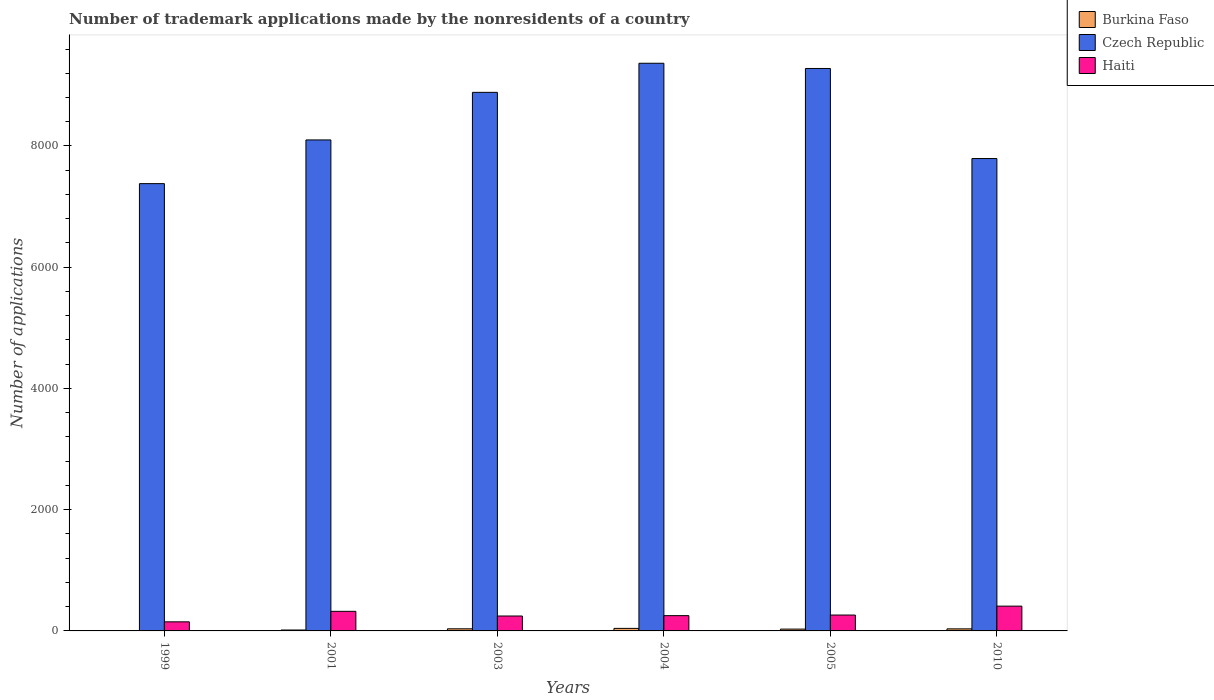How many groups of bars are there?
Make the answer very short. 6. Are the number of bars per tick equal to the number of legend labels?
Offer a very short reply. Yes. Are the number of bars on each tick of the X-axis equal?
Your response must be concise. Yes. How many bars are there on the 4th tick from the left?
Provide a short and direct response. 3. What is the label of the 5th group of bars from the left?
Provide a succinct answer. 2005. What is the number of trademark applications made by the nonresidents in Czech Republic in 2003?
Ensure brevity in your answer.  8885. Across all years, what is the maximum number of trademark applications made by the nonresidents in Czech Republic?
Make the answer very short. 9365. Across all years, what is the minimum number of trademark applications made by the nonresidents in Haiti?
Keep it short and to the point. 150. What is the total number of trademark applications made by the nonresidents in Burkina Faso in the graph?
Your answer should be very brief. 157. What is the difference between the number of trademark applications made by the nonresidents in Haiti in 2004 and that in 2010?
Provide a short and direct response. -157. What is the difference between the number of trademark applications made by the nonresidents in Haiti in 2003 and the number of trademark applications made by the nonresidents in Burkina Faso in 1999?
Offer a very short reply. 245. What is the average number of trademark applications made by the nonresidents in Burkina Faso per year?
Provide a short and direct response. 26.17. In the year 1999, what is the difference between the number of trademark applications made by the nonresidents in Haiti and number of trademark applications made by the nonresidents in Burkina Faso?
Your response must be concise. 149. What is the ratio of the number of trademark applications made by the nonresidents in Haiti in 1999 to that in 2001?
Provide a succinct answer. 0.46. Is the number of trademark applications made by the nonresidents in Haiti in 2001 less than that in 2005?
Provide a short and direct response. No. What is the difference between the highest and the lowest number of trademark applications made by the nonresidents in Czech Republic?
Offer a very short reply. 1986. In how many years, is the number of trademark applications made by the nonresidents in Burkina Faso greater than the average number of trademark applications made by the nonresidents in Burkina Faso taken over all years?
Keep it short and to the point. 4. Is the sum of the number of trademark applications made by the nonresidents in Haiti in 2005 and 2010 greater than the maximum number of trademark applications made by the nonresidents in Burkina Faso across all years?
Make the answer very short. Yes. What does the 3rd bar from the left in 2005 represents?
Offer a terse response. Haiti. What does the 1st bar from the right in 2001 represents?
Provide a short and direct response. Haiti. Is it the case that in every year, the sum of the number of trademark applications made by the nonresidents in Burkina Faso and number of trademark applications made by the nonresidents in Haiti is greater than the number of trademark applications made by the nonresidents in Czech Republic?
Offer a very short reply. No. What is the difference between two consecutive major ticks on the Y-axis?
Give a very brief answer. 2000. Does the graph contain any zero values?
Offer a terse response. No. What is the title of the graph?
Give a very brief answer. Number of trademark applications made by the nonresidents of a country. Does "Egypt, Arab Rep." appear as one of the legend labels in the graph?
Offer a very short reply. No. What is the label or title of the Y-axis?
Give a very brief answer. Number of applications. What is the Number of applications of Czech Republic in 1999?
Keep it short and to the point. 7379. What is the Number of applications in Haiti in 1999?
Offer a very short reply. 150. What is the Number of applications in Burkina Faso in 2001?
Your answer should be compact. 15. What is the Number of applications of Czech Republic in 2001?
Your response must be concise. 8100. What is the Number of applications of Haiti in 2001?
Make the answer very short. 323. What is the Number of applications in Czech Republic in 2003?
Give a very brief answer. 8885. What is the Number of applications in Haiti in 2003?
Ensure brevity in your answer.  246. What is the Number of applications in Czech Republic in 2004?
Provide a succinct answer. 9365. What is the Number of applications in Haiti in 2004?
Make the answer very short. 252. What is the Number of applications in Czech Republic in 2005?
Offer a terse response. 9279. What is the Number of applications of Haiti in 2005?
Offer a very short reply. 262. What is the Number of applications in Burkina Faso in 2010?
Your answer should be very brief. 34. What is the Number of applications in Czech Republic in 2010?
Provide a short and direct response. 7793. What is the Number of applications in Haiti in 2010?
Offer a very short reply. 409. Across all years, what is the maximum Number of applications in Czech Republic?
Offer a terse response. 9365. Across all years, what is the maximum Number of applications in Haiti?
Offer a very short reply. 409. Across all years, what is the minimum Number of applications of Czech Republic?
Make the answer very short. 7379. Across all years, what is the minimum Number of applications of Haiti?
Your answer should be very brief. 150. What is the total Number of applications of Burkina Faso in the graph?
Your response must be concise. 157. What is the total Number of applications in Czech Republic in the graph?
Ensure brevity in your answer.  5.08e+04. What is the total Number of applications of Haiti in the graph?
Keep it short and to the point. 1642. What is the difference between the Number of applications of Burkina Faso in 1999 and that in 2001?
Provide a succinct answer. -14. What is the difference between the Number of applications of Czech Republic in 1999 and that in 2001?
Your answer should be very brief. -721. What is the difference between the Number of applications of Haiti in 1999 and that in 2001?
Offer a terse response. -173. What is the difference between the Number of applications of Burkina Faso in 1999 and that in 2003?
Keep it short and to the point. -34. What is the difference between the Number of applications in Czech Republic in 1999 and that in 2003?
Offer a very short reply. -1506. What is the difference between the Number of applications in Haiti in 1999 and that in 2003?
Give a very brief answer. -96. What is the difference between the Number of applications in Burkina Faso in 1999 and that in 2004?
Make the answer very short. -41. What is the difference between the Number of applications in Czech Republic in 1999 and that in 2004?
Provide a succinct answer. -1986. What is the difference between the Number of applications in Haiti in 1999 and that in 2004?
Make the answer very short. -102. What is the difference between the Number of applications in Czech Republic in 1999 and that in 2005?
Provide a succinct answer. -1900. What is the difference between the Number of applications of Haiti in 1999 and that in 2005?
Offer a terse response. -112. What is the difference between the Number of applications in Burkina Faso in 1999 and that in 2010?
Ensure brevity in your answer.  -33. What is the difference between the Number of applications in Czech Republic in 1999 and that in 2010?
Your answer should be compact. -414. What is the difference between the Number of applications in Haiti in 1999 and that in 2010?
Keep it short and to the point. -259. What is the difference between the Number of applications in Czech Republic in 2001 and that in 2003?
Keep it short and to the point. -785. What is the difference between the Number of applications in Czech Republic in 2001 and that in 2004?
Give a very brief answer. -1265. What is the difference between the Number of applications of Czech Republic in 2001 and that in 2005?
Your answer should be compact. -1179. What is the difference between the Number of applications of Czech Republic in 2001 and that in 2010?
Give a very brief answer. 307. What is the difference between the Number of applications in Haiti in 2001 and that in 2010?
Ensure brevity in your answer.  -86. What is the difference between the Number of applications in Burkina Faso in 2003 and that in 2004?
Offer a terse response. -7. What is the difference between the Number of applications in Czech Republic in 2003 and that in 2004?
Make the answer very short. -480. What is the difference between the Number of applications in Burkina Faso in 2003 and that in 2005?
Keep it short and to the point. 5. What is the difference between the Number of applications of Czech Republic in 2003 and that in 2005?
Make the answer very short. -394. What is the difference between the Number of applications in Czech Republic in 2003 and that in 2010?
Ensure brevity in your answer.  1092. What is the difference between the Number of applications in Haiti in 2003 and that in 2010?
Offer a terse response. -163. What is the difference between the Number of applications of Burkina Faso in 2004 and that in 2010?
Give a very brief answer. 8. What is the difference between the Number of applications in Czech Republic in 2004 and that in 2010?
Your answer should be very brief. 1572. What is the difference between the Number of applications in Haiti in 2004 and that in 2010?
Make the answer very short. -157. What is the difference between the Number of applications of Czech Republic in 2005 and that in 2010?
Make the answer very short. 1486. What is the difference between the Number of applications of Haiti in 2005 and that in 2010?
Provide a short and direct response. -147. What is the difference between the Number of applications in Burkina Faso in 1999 and the Number of applications in Czech Republic in 2001?
Your answer should be compact. -8099. What is the difference between the Number of applications in Burkina Faso in 1999 and the Number of applications in Haiti in 2001?
Provide a short and direct response. -322. What is the difference between the Number of applications in Czech Republic in 1999 and the Number of applications in Haiti in 2001?
Offer a very short reply. 7056. What is the difference between the Number of applications of Burkina Faso in 1999 and the Number of applications of Czech Republic in 2003?
Your answer should be compact. -8884. What is the difference between the Number of applications of Burkina Faso in 1999 and the Number of applications of Haiti in 2003?
Keep it short and to the point. -245. What is the difference between the Number of applications of Czech Republic in 1999 and the Number of applications of Haiti in 2003?
Your response must be concise. 7133. What is the difference between the Number of applications in Burkina Faso in 1999 and the Number of applications in Czech Republic in 2004?
Offer a very short reply. -9364. What is the difference between the Number of applications of Burkina Faso in 1999 and the Number of applications of Haiti in 2004?
Your response must be concise. -251. What is the difference between the Number of applications in Czech Republic in 1999 and the Number of applications in Haiti in 2004?
Your response must be concise. 7127. What is the difference between the Number of applications in Burkina Faso in 1999 and the Number of applications in Czech Republic in 2005?
Offer a very short reply. -9278. What is the difference between the Number of applications of Burkina Faso in 1999 and the Number of applications of Haiti in 2005?
Keep it short and to the point. -261. What is the difference between the Number of applications in Czech Republic in 1999 and the Number of applications in Haiti in 2005?
Make the answer very short. 7117. What is the difference between the Number of applications of Burkina Faso in 1999 and the Number of applications of Czech Republic in 2010?
Your response must be concise. -7792. What is the difference between the Number of applications in Burkina Faso in 1999 and the Number of applications in Haiti in 2010?
Ensure brevity in your answer.  -408. What is the difference between the Number of applications of Czech Republic in 1999 and the Number of applications of Haiti in 2010?
Your response must be concise. 6970. What is the difference between the Number of applications of Burkina Faso in 2001 and the Number of applications of Czech Republic in 2003?
Make the answer very short. -8870. What is the difference between the Number of applications in Burkina Faso in 2001 and the Number of applications in Haiti in 2003?
Your answer should be compact. -231. What is the difference between the Number of applications of Czech Republic in 2001 and the Number of applications of Haiti in 2003?
Provide a short and direct response. 7854. What is the difference between the Number of applications of Burkina Faso in 2001 and the Number of applications of Czech Republic in 2004?
Keep it short and to the point. -9350. What is the difference between the Number of applications in Burkina Faso in 2001 and the Number of applications in Haiti in 2004?
Your answer should be compact. -237. What is the difference between the Number of applications in Czech Republic in 2001 and the Number of applications in Haiti in 2004?
Keep it short and to the point. 7848. What is the difference between the Number of applications of Burkina Faso in 2001 and the Number of applications of Czech Republic in 2005?
Keep it short and to the point. -9264. What is the difference between the Number of applications of Burkina Faso in 2001 and the Number of applications of Haiti in 2005?
Ensure brevity in your answer.  -247. What is the difference between the Number of applications of Czech Republic in 2001 and the Number of applications of Haiti in 2005?
Ensure brevity in your answer.  7838. What is the difference between the Number of applications in Burkina Faso in 2001 and the Number of applications in Czech Republic in 2010?
Your answer should be very brief. -7778. What is the difference between the Number of applications in Burkina Faso in 2001 and the Number of applications in Haiti in 2010?
Provide a succinct answer. -394. What is the difference between the Number of applications in Czech Republic in 2001 and the Number of applications in Haiti in 2010?
Provide a short and direct response. 7691. What is the difference between the Number of applications of Burkina Faso in 2003 and the Number of applications of Czech Republic in 2004?
Your answer should be compact. -9330. What is the difference between the Number of applications in Burkina Faso in 2003 and the Number of applications in Haiti in 2004?
Provide a short and direct response. -217. What is the difference between the Number of applications of Czech Republic in 2003 and the Number of applications of Haiti in 2004?
Offer a terse response. 8633. What is the difference between the Number of applications in Burkina Faso in 2003 and the Number of applications in Czech Republic in 2005?
Give a very brief answer. -9244. What is the difference between the Number of applications of Burkina Faso in 2003 and the Number of applications of Haiti in 2005?
Your answer should be very brief. -227. What is the difference between the Number of applications of Czech Republic in 2003 and the Number of applications of Haiti in 2005?
Provide a short and direct response. 8623. What is the difference between the Number of applications in Burkina Faso in 2003 and the Number of applications in Czech Republic in 2010?
Your answer should be compact. -7758. What is the difference between the Number of applications of Burkina Faso in 2003 and the Number of applications of Haiti in 2010?
Give a very brief answer. -374. What is the difference between the Number of applications of Czech Republic in 2003 and the Number of applications of Haiti in 2010?
Offer a terse response. 8476. What is the difference between the Number of applications in Burkina Faso in 2004 and the Number of applications in Czech Republic in 2005?
Give a very brief answer. -9237. What is the difference between the Number of applications in Burkina Faso in 2004 and the Number of applications in Haiti in 2005?
Give a very brief answer. -220. What is the difference between the Number of applications in Czech Republic in 2004 and the Number of applications in Haiti in 2005?
Offer a very short reply. 9103. What is the difference between the Number of applications of Burkina Faso in 2004 and the Number of applications of Czech Republic in 2010?
Give a very brief answer. -7751. What is the difference between the Number of applications in Burkina Faso in 2004 and the Number of applications in Haiti in 2010?
Provide a short and direct response. -367. What is the difference between the Number of applications in Czech Republic in 2004 and the Number of applications in Haiti in 2010?
Give a very brief answer. 8956. What is the difference between the Number of applications of Burkina Faso in 2005 and the Number of applications of Czech Republic in 2010?
Give a very brief answer. -7763. What is the difference between the Number of applications of Burkina Faso in 2005 and the Number of applications of Haiti in 2010?
Provide a succinct answer. -379. What is the difference between the Number of applications of Czech Republic in 2005 and the Number of applications of Haiti in 2010?
Offer a terse response. 8870. What is the average Number of applications in Burkina Faso per year?
Your response must be concise. 26.17. What is the average Number of applications of Czech Republic per year?
Ensure brevity in your answer.  8466.83. What is the average Number of applications in Haiti per year?
Your answer should be compact. 273.67. In the year 1999, what is the difference between the Number of applications in Burkina Faso and Number of applications in Czech Republic?
Your response must be concise. -7378. In the year 1999, what is the difference between the Number of applications of Burkina Faso and Number of applications of Haiti?
Your response must be concise. -149. In the year 1999, what is the difference between the Number of applications of Czech Republic and Number of applications of Haiti?
Provide a short and direct response. 7229. In the year 2001, what is the difference between the Number of applications of Burkina Faso and Number of applications of Czech Republic?
Provide a succinct answer. -8085. In the year 2001, what is the difference between the Number of applications in Burkina Faso and Number of applications in Haiti?
Offer a terse response. -308. In the year 2001, what is the difference between the Number of applications of Czech Republic and Number of applications of Haiti?
Your response must be concise. 7777. In the year 2003, what is the difference between the Number of applications of Burkina Faso and Number of applications of Czech Republic?
Give a very brief answer. -8850. In the year 2003, what is the difference between the Number of applications of Burkina Faso and Number of applications of Haiti?
Offer a terse response. -211. In the year 2003, what is the difference between the Number of applications in Czech Republic and Number of applications in Haiti?
Offer a terse response. 8639. In the year 2004, what is the difference between the Number of applications of Burkina Faso and Number of applications of Czech Republic?
Offer a very short reply. -9323. In the year 2004, what is the difference between the Number of applications in Burkina Faso and Number of applications in Haiti?
Offer a very short reply. -210. In the year 2004, what is the difference between the Number of applications of Czech Republic and Number of applications of Haiti?
Your response must be concise. 9113. In the year 2005, what is the difference between the Number of applications in Burkina Faso and Number of applications in Czech Republic?
Offer a terse response. -9249. In the year 2005, what is the difference between the Number of applications in Burkina Faso and Number of applications in Haiti?
Offer a terse response. -232. In the year 2005, what is the difference between the Number of applications of Czech Republic and Number of applications of Haiti?
Your answer should be very brief. 9017. In the year 2010, what is the difference between the Number of applications in Burkina Faso and Number of applications in Czech Republic?
Provide a succinct answer. -7759. In the year 2010, what is the difference between the Number of applications of Burkina Faso and Number of applications of Haiti?
Give a very brief answer. -375. In the year 2010, what is the difference between the Number of applications in Czech Republic and Number of applications in Haiti?
Your response must be concise. 7384. What is the ratio of the Number of applications in Burkina Faso in 1999 to that in 2001?
Give a very brief answer. 0.07. What is the ratio of the Number of applications in Czech Republic in 1999 to that in 2001?
Provide a short and direct response. 0.91. What is the ratio of the Number of applications in Haiti in 1999 to that in 2001?
Your response must be concise. 0.46. What is the ratio of the Number of applications in Burkina Faso in 1999 to that in 2003?
Offer a terse response. 0.03. What is the ratio of the Number of applications in Czech Republic in 1999 to that in 2003?
Keep it short and to the point. 0.83. What is the ratio of the Number of applications in Haiti in 1999 to that in 2003?
Ensure brevity in your answer.  0.61. What is the ratio of the Number of applications in Burkina Faso in 1999 to that in 2004?
Your answer should be compact. 0.02. What is the ratio of the Number of applications of Czech Republic in 1999 to that in 2004?
Give a very brief answer. 0.79. What is the ratio of the Number of applications of Haiti in 1999 to that in 2004?
Your response must be concise. 0.6. What is the ratio of the Number of applications of Burkina Faso in 1999 to that in 2005?
Your answer should be very brief. 0.03. What is the ratio of the Number of applications in Czech Republic in 1999 to that in 2005?
Ensure brevity in your answer.  0.8. What is the ratio of the Number of applications of Haiti in 1999 to that in 2005?
Your answer should be very brief. 0.57. What is the ratio of the Number of applications in Burkina Faso in 1999 to that in 2010?
Your answer should be very brief. 0.03. What is the ratio of the Number of applications of Czech Republic in 1999 to that in 2010?
Provide a succinct answer. 0.95. What is the ratio of the Number of applications in Haiti in 1999 to that in 2010?
Your answer should be very brief. 0.37. What is the ratio of the Number of applications in Burkina Faso in 2001 to that in 2003?
Provide a short and direct response. 0.43. What is the ratio of the Number of applications of Czech Republic in 2001 to that in 2003?
Make the answer very short. 0.91. What is the ratio of the Number of applications in Haiti in 2001 to that in 2003?
Make the answer very short. 1.31. What is the ratio of the Number of applications in Burkina Faso in 2001 to that in 2004?
Ensure brevity in your answer.  0.36. What is the ratio of the Number of applications of Czech Republic in 2001 to that in 2004?
Provide a succinct answer. 0.86. What is the ratio of the Number of applications of Haiti in 2001 to that in 2004?
Your response must be concise. 1.28. What is the ratio of the Number of applications in Czech Republic in 2001 to that in 2005?
Ensure brevity in your answer.  0.87. What is the ratio of the Number of applications of Haiti in 2001 to that in 2005?
Your answer should be compact. 1.23. What is the ratio of the Number of applications in Burkina Faso in 2001 to that in 2010?
Your answer should be compact. 0.44. What is the ratio of the Number of applications of Czech Republic in 2001 to that in 2010?
Provide a short and direct response. 1.04. What is the ratio of the Number of applications in Haiti in 2001 to that in 2010?
Your response must be concise. 0.79. What is the ratio of the Number of applications in Czech Republic in 2003 to that in 2004?
Make the answer very short. 0.95. What is the ratio of the Number of applications of Haiti in 2003 to that in 2004?
Offer a terse response. 0.98. What is the ratio of the Number of applications of Czech Republic in 2003 to that in 2005?
Provide a short and direct response. 0.96. What is the ratio of the Number of applications in Haiti in 2003 to that in 2005?
Ensure brevity in your answer.  0.94. What is the ratio of the Number of applications of Burkina Faso in 2003 to that in 2010?
Your response must be concise. 1.03. What is the ratio of the Number of applications in Czech Republic in 2003 to that in 2010?
Ensure brevity in your answer.  1.14. What is the ratio of the Number of applications in Haiti in 2003 to that in 2010?
Ensure brevity in your answer.  0.6. What is the ratio of the Number of applications in Burkina Faso in 2004 to that in 2005?
Offer a very short reply. 1.4. What is the ratio of the Number of applications in Czech Republic in 2004 to that in 2005?
Keep it short and to the point. 1.01. What is the ratio of the Number of applications in Haiti in 2004 to that in 2005?
Offer a terse response. 0.96. What is the ratio of the Number of applications in Burkina Faso in 2004 to that in 2010?
Your answer should be very brief. 1.24. What is the ratio of the Number of applications of Czech Republic in 2004 to that in 2010?
Your response must be concise. 1.2. What is the ratio of the Number of applications in Haiti in 2004 to that in 2010?
Provide a short and direct response. 0.62. What is the ratio of the Number of applications of Burkina Faso in 2005 to that in 2010?
Provide a succinct answer. 0.88. What is the ratio of the Number of applications of Czech Republic in 2005 to that in 2010?
Offer a terse response. 1.19. What is the ratio of the Number of applications in Haiti in 2005 to that in 2010?
Offer a terse response. 0.64. What is the difference between the highest and the lowest Number of applications of Burkina Faso?
Your answer should be very brief. 41. What is the difference between the highest and the lowest Number of applications in Czech Republic?
Offer a terse response. 1986. What is the difference between the highest and the lowest Number of applications in Haiti?
Ensure brevity in your answer.  259. 